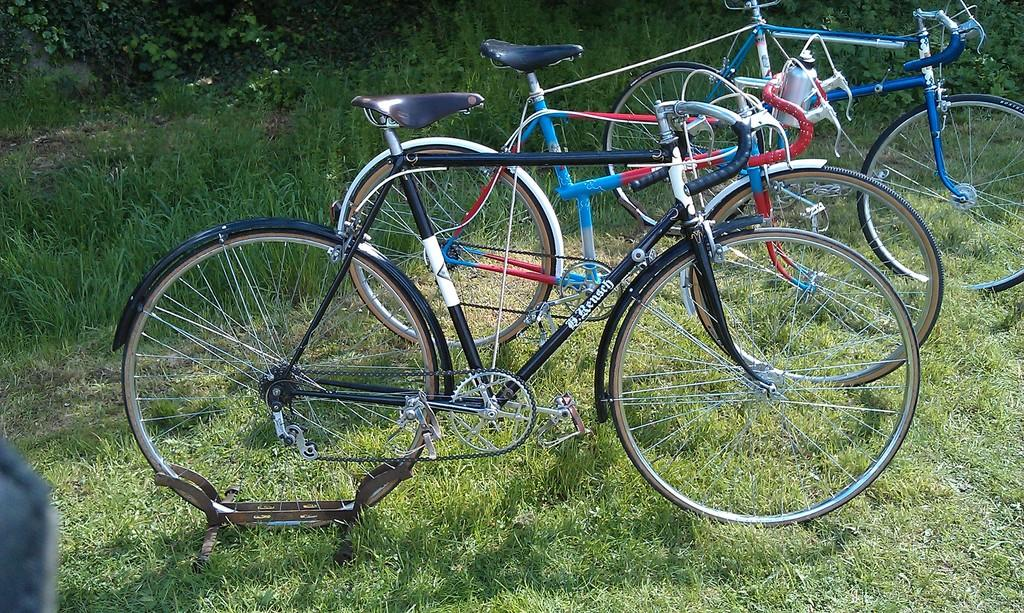What is the main subject of the image? The main subject of the image is bicycles. Where are the bicycles located? The bicycles are on a grassland. What can be seen at the top side of the image? There are plants at the top side of the image. How many thumbs can be seen on the bicycles in the image? There are no thumbs visible on the bicycles in the image. Is there a gate present in the image? There is no gate present in the image. 